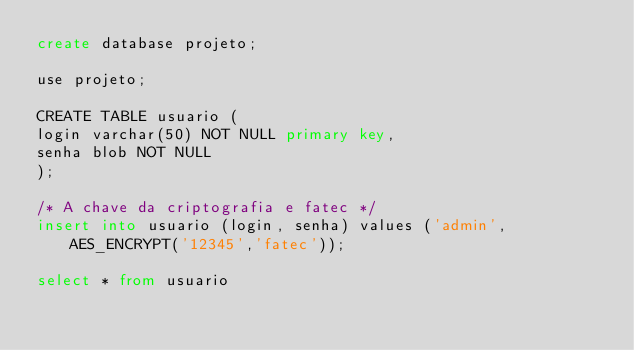Convert code to text. <code><loc_0><loc_0><loc_500><loc_500><_SQL_>create database projeto;

use projeto;

CREATE TABLE usuario (
login varchar(50) NOT NULL primary key,
senha blob NOT NULL
);

/* A chave da criptografia e fatec */
insert into usuario (login, senha) values ('admin', AES_ENCRYPT('12345','fatec'));

select * from usuario</code> 